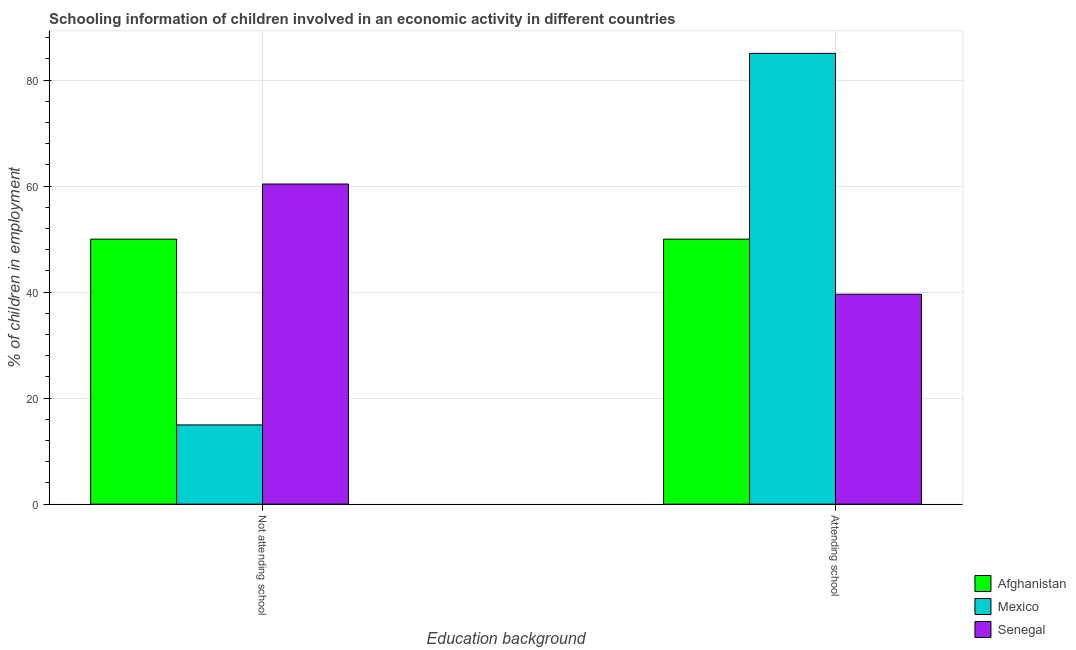How many different coloured bars are there?
Offer a terse response. 3. Are the number of bars on each tick of the X-axis equal?
Your response must be concise. Yes. How many bars are there on the 2nd tick from the right?
Your response must be concise. 3. What is the label of the 2nd group of bars from the left?
Give a very brief answer. Attending school. What is the percentage of employed children who are attending school in Senegal?
Your answer should be compact. 39.6. Across all countries, what is the maximum percentage of employed children who are not attending school?
Give a very brief answer. 60.4. Across all countries, what is the minimum percentage of employed children who are attending school?
Your answer should be compact. 39.6. In which country was the percentage of employed children who are attending school minimum?
Offer a very short reply. Senegal. What is the total percentage of employed children who are not attending school in the graph?
Offer a terse response. 125.35. What is the difference between the percentage of employed children who are attending school in Afghanistan and that in Mexico?
Offer a terse response. -35.05. What is the difference between the percentage of employed children who are not attending school in Senegal and the percentage of employed children who are attending school in Mexico?
Provide a succinct answer. -24.65. What is the average percentage of employed children who are not attending school per country?
Your response must be concise. 41.78. What is the difference between the percentage of employed children who are not attending school and percentage of employed children who are attending school in Senegal?
Your answer should be very brief. 20.8. What is the ratio of the percentage of employed children who are not attending school in Mexico to that in Senegal?
Ensure brevity in your answer.  0.25. What does the 1st bar from the left in Attending school represents?
Give a very brief answer. Afghanistan. What does the 3rd bar from the right in Attending school represents?
Give a very brief answer. Afghanistan. How many countries are there in the graph?
Offer a very short reply. 3. What is the difference between two consecutive major ticks on the Y-axis?
Provide a short and direct response. 20. Are the values on the major ticks of Y-axis written in scientific E-notation?
Offer a terse response. No. Does the graph contain grids?
Ensure brevity in your answer.  Yes. How are the legend labels stacked?
Your response must be concise. Vertical. What is the title of the graph?
Keep it short and to the point. Schooling information of children involved in an economic activity in different countries. Does "Solomon Islands" appear as one of the legend labels in the graph?
Make the answer very short. No. What is the label or title of the X-axis?
Offer a terse response. Education background. What is the label or title of the Y-axis?
Offer a very short reply. % of children in employment. What is the % of children in employment of Mexico in Not attending school?
Ensure brevity in your answer.  14.95. What is the % of children in employment in Senegal in Not attending school?
Ensure brevity in your answer.  60.4. What is the % of children in employment in Mexico in Attending school?
Offer a very short reply. 85.05. What is the % of children in employment in Senegal in Attending school?
Make the answer very short. 39.6. Across all Education background, what is the maximum % of children in employment in Mexico?
Make the answer very short. 85.05. Across all Education background, what is the maximum % of children in employment of Senegal?
Give a very brief answer. 60.4. Across all Education background, what is the minimum % of children in employment of Afghanistan?
Offer a terse response. 50. Across all Education background, what is the minimum % of children in employment in Mexico?
Keep it short and to the point. 14.95. Across all Education background, what is the minimum % of children in employment in Senegal?
Your answer should be compact. 39.6. What is the total % of children in employment of Afghanistan in the graph?
Give a very brief answer. 100. What is the total % of children in employment in Mexico in the graph?
Offer a terse response. 100. What is the total % of children in employment in Senegal in the graph?
Your answer should be very brief. 100. What is the difference between the % of children in employment in Mexico in Not attending school and that in Attending school?
Keep it short and to the point. -70.1. What is the difference between the % of children in employment in Senegal in Not attending school and that in Attending school?
Your response must be concise. 20.8. What is the difference between the % of children in employment in Afghanistan in Not attending school and the % of children in employment in Mexico in Attending school?
Your answer should be compact. -35.05. What is the difference between the % of children in employment of Mexico in Not attending school and the % of children in employment of Senegal in Attending school?
Your response must be concise. -24.65. What is the average % of children in employment of Senegal per Education background?
Your answer should be compact. 50. What is the difference between the % of children in employment in Afghanistan and % of children in employment in Mexico in Not attending school?
Offer a very short reply. 35.05. What is the difference between the % of children in employment of Afghanistan and % of children in employment of Senegal in Not attending school?
Ensure brevity in your answer.  -10.4. What is the difference between the % of children in employment of Mexico and % of children in employment of Senegal in Not attending school?
Offer a very short reply. -45.45. What is the difference between the % of children in employment of Afghanistan and % of children in employment of Mexico in Attending school?
Make the answer very short. -35.05. What is the difference between the % of children in employment of Mexico and % of children in employment of Senegal in Attending school?
Your response must be concise. 45.45. What is the ratio of the % of children in employment in Mexico in Not attending school to that in Attending school?
Provide a succinct answer. 0.18. What is the ratio of the % of children in employment of Senegal in Not attending school to that in Attending school?
Provide a short and direct response. 1.53. What is the difference between the highest and the second highest % of children in employment of Afghanistan?
Your answer should be compact. 0. What is the difference between the highest and the second highest % of children in employment of Mexico?
Keep it short and to the point. 70.1. What is the difference between the highest and the second highest % of children in employment in Senegal?
Offer a terse response. 20.8. What is the difference between the highest and the lowest % of children in employment in Mexico?
Provide a succinct answer. 70.1. What is the difference between the highest and the lowest % of children in employment in Senegal?
Your answer should be compact. 20.8. 